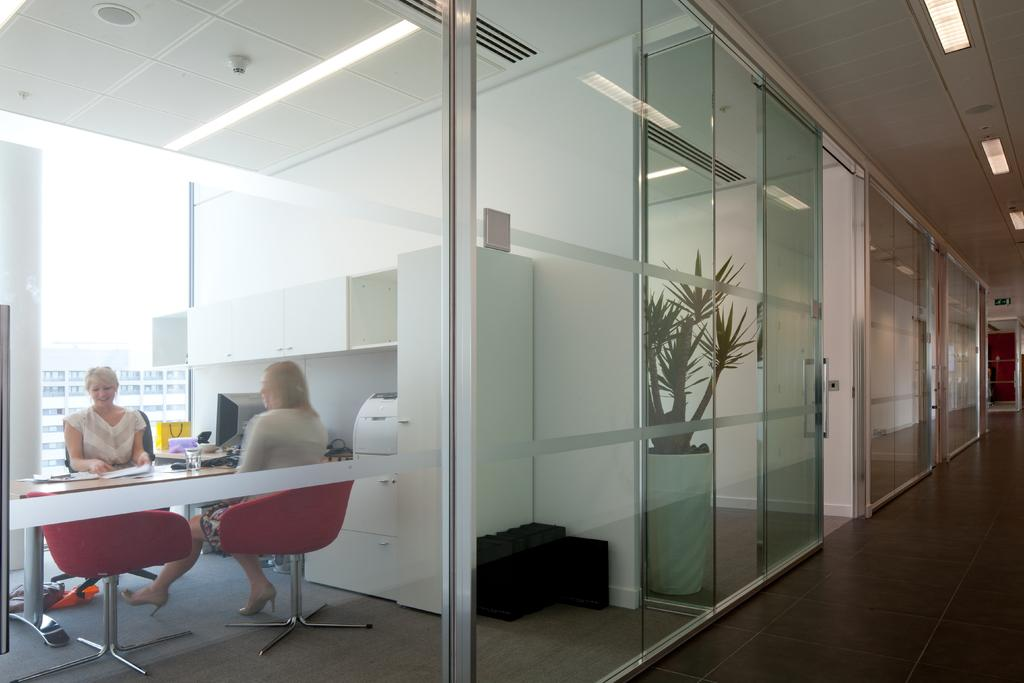What is the woman in the image doing? The woman is sitting on a chair in the image. What is in front of the chair? There is a table in front of the chair. What is on the table? There is a glass on the table, and there are objects on the table as well. What can be seen through the glass door in the image? The glass door is visible in the image, but the scene beyond it cannot be determined from the provided facts. What is near the glass door? There is a flower pot in the image. What school does the woman attend in the image? There is no indication in the image that the woman is attending a school. What act is the woman performing in the image? The image does not depict the woman performing any specific act or action. 